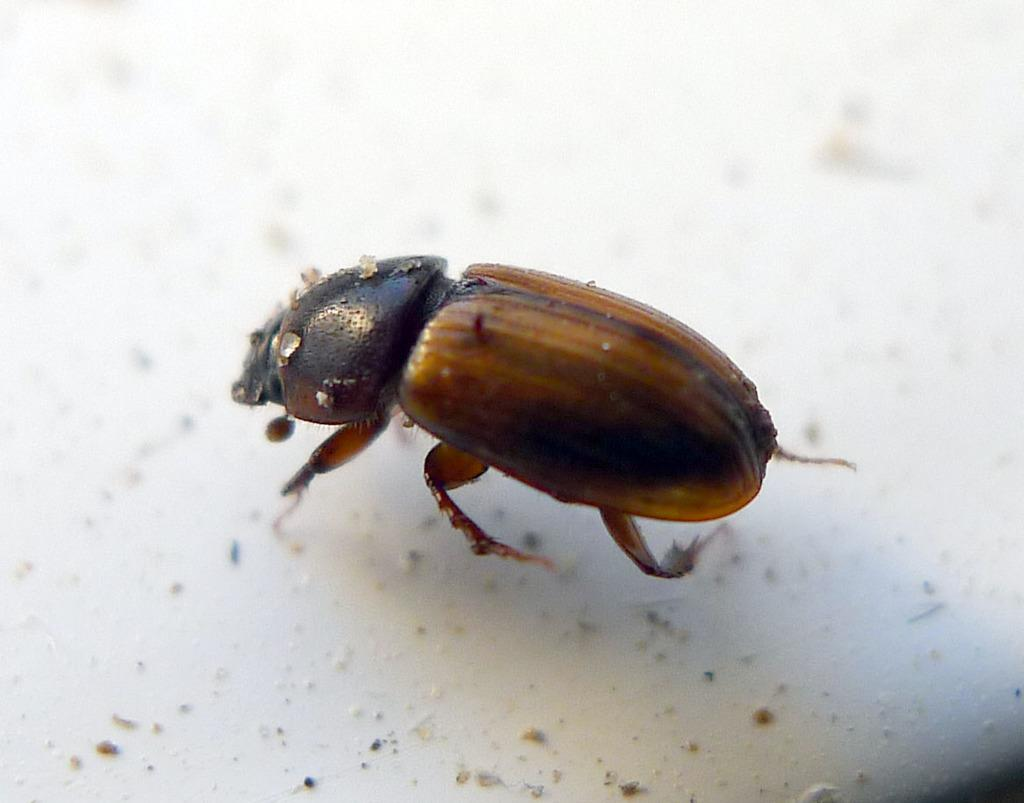What is the main subject in the center of the image? There is an insect in the center of the image. What type of surface is the insect on? The insect is on a white-colored surface. How many cushions are present in the image? There are no cushions present in the image; it features an insect on a white-colored surface. What year is depicted in the image? The image does not depict a specific year; it features an insect on a white-colored surface. 